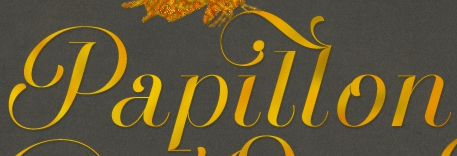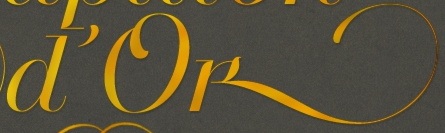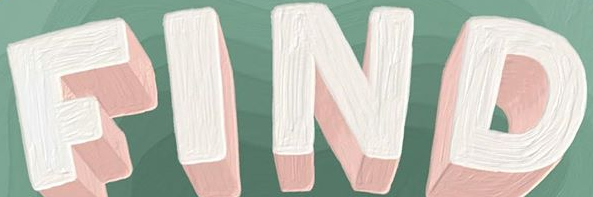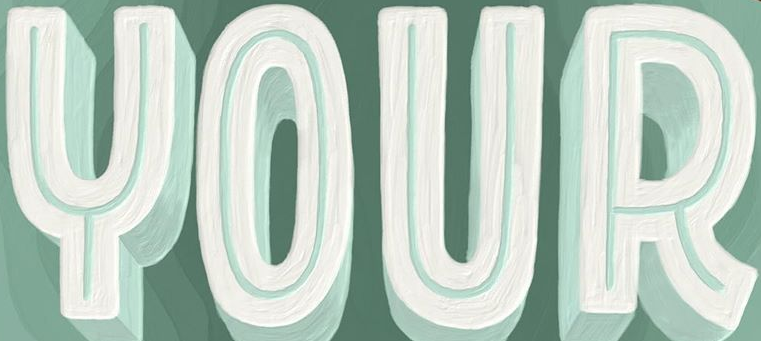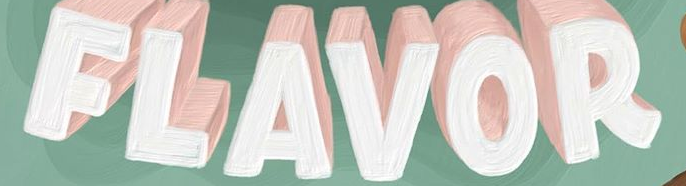Transcribe the words shown in these images in order, separated by a semicolon. Papillon; D'ok; FIND; YOUR; FLAVOR 